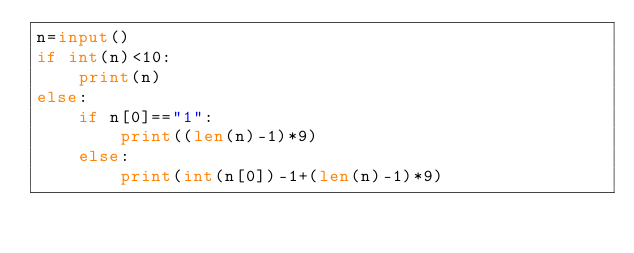Convert code to text. <code><loc_0><loc_0><loc_500><loc_500><_Python_>n=input()
if int(n)<10:
    print(n)
else:
    if n[0]=="1":
        print((len(n)-1)*9)
    else:
        print(int(n[0])-1+(len(n)-1)*9)</code> 